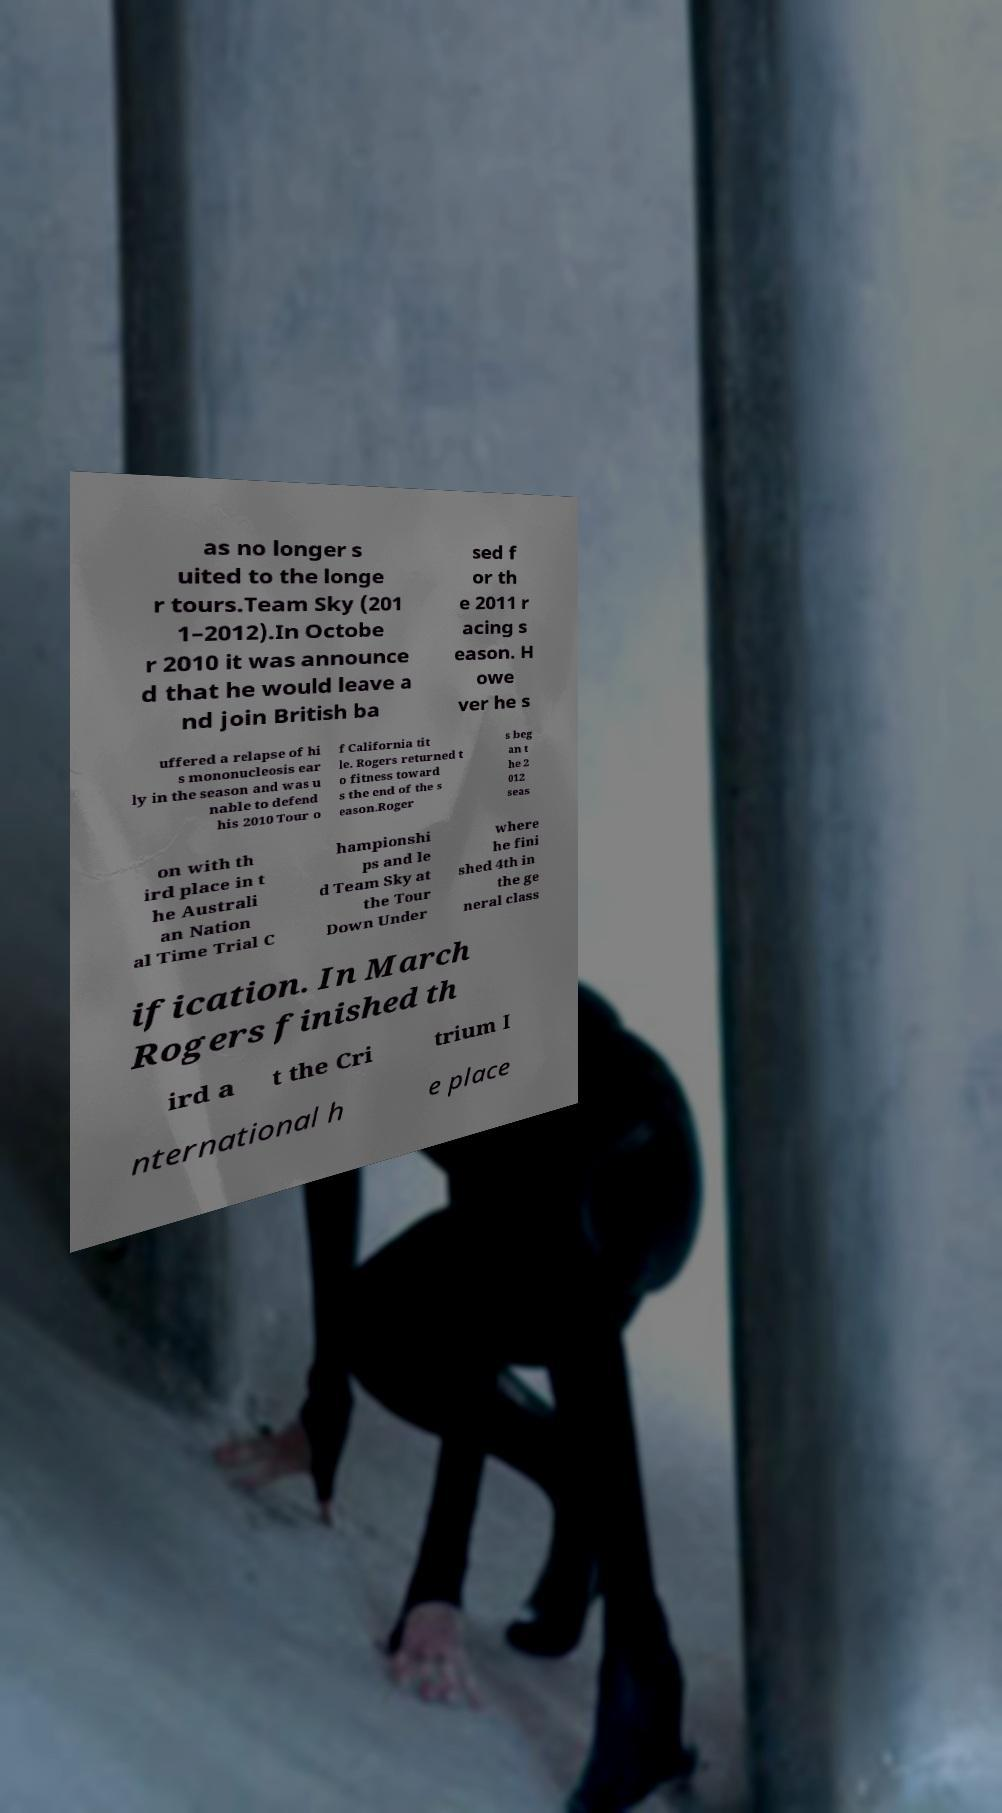Can you read and provide the text displayed in the image?This photo seems to have some interesting text. Can you extract and type it out for me? as no longer s uited to the longe r tours.Team Sky (201 1–2012).In Octobe r 2010 it was announce d that he would leave a nd join British ba sed f or th e 2011 r acing s eason. H owe ver he s uffered a relapse of hi s mononucleosis ear ly in the season and was u nable to defend his 2010 Tour o f California tit le. Rogers returned t o fitness toward s the end of the s eason.Roger s beg an t he 2 012 seas on with th ird place in t he Australi an Nation al Time Trial C hampionshi ps and le d Team Sky at the Tour Down Under where he fini shed 4th in the ge neral class ification. In March Rogers finished th ird a t the Cri trium I nternational h e place 